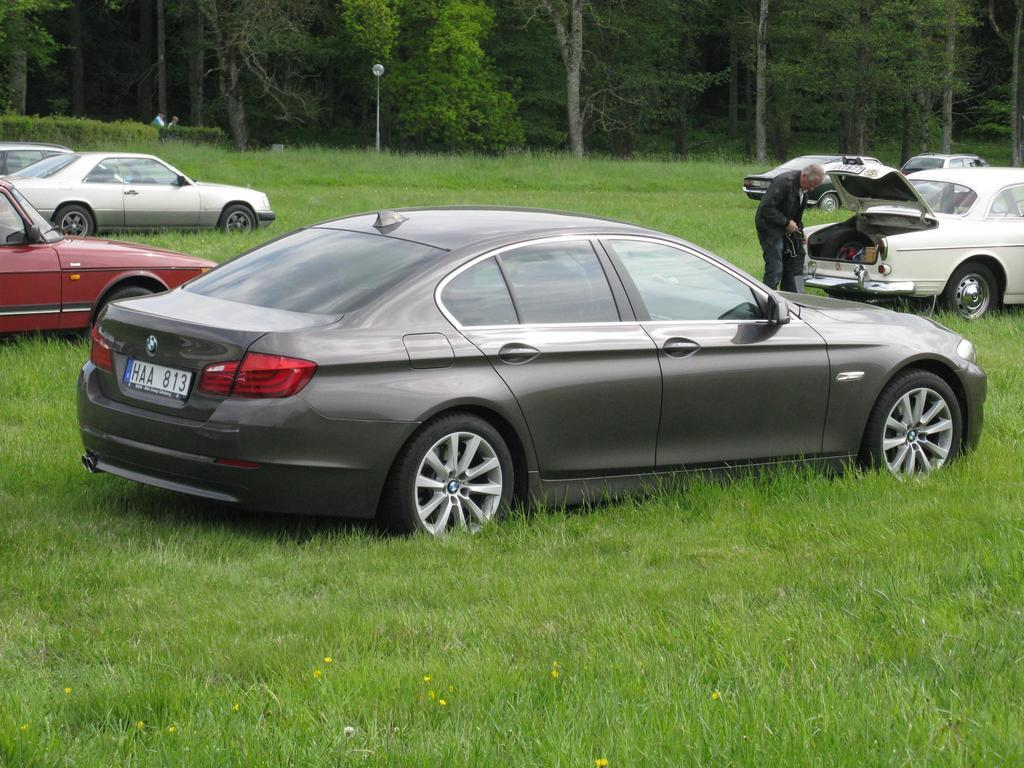What is located on the grass in the image? There are vehicles on the grass in the image. What can be seen in the image that provides illumination? There is a light in the image. What structure is present in the image that supports the light? There is a pole in the image. How many people are standing in the image? There are three persons standing in the image. What is visible in the background of the image? There are trees in the background of the image. What degree does the person in the vest hold in the image? There is no person wearing a vest or holding a degree in the image. Who is the aunt in the image? There is no mention of an aunt or any family relationships in the image. 